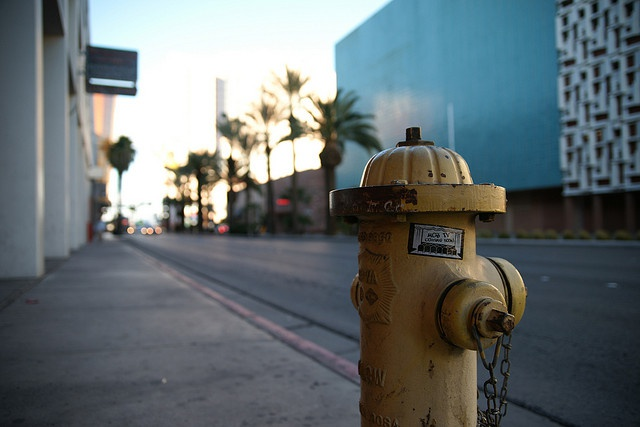Describe the objects in this image and their specific colors. I can see a fire hydrant in black, olive, and gray tones in this image. 